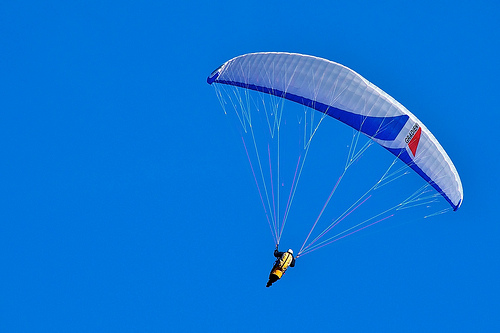What color is the vest, yellow or blue? The vest the person is wearing is yellow. 